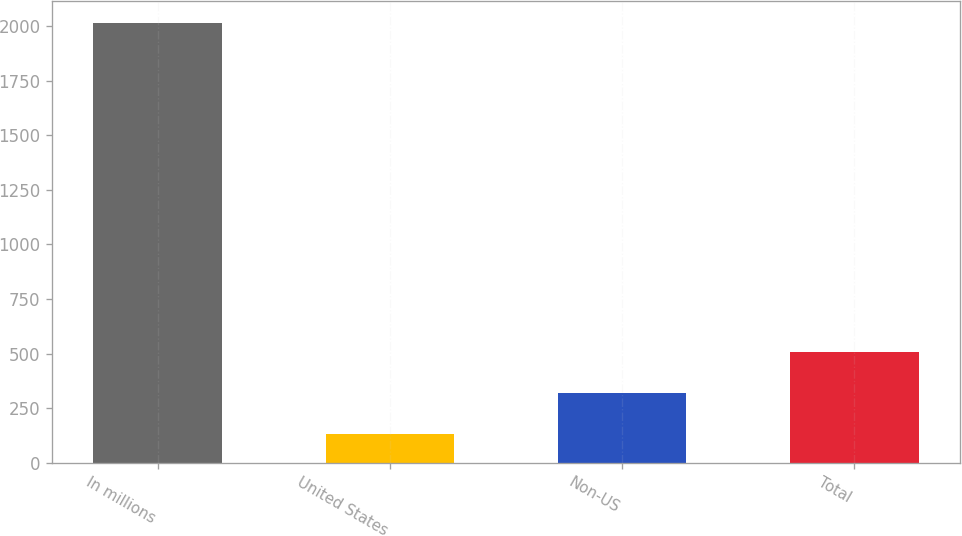Convert chart. <chart><loc_0><loc_0><loc_500><loc_500><bar_chart><fcel>In millions<fcel>United States<fcel>Non-US<fcel>Total<nl><fcel>2016<fcel>129.9<fcel>318.51<fcel>507.12<nl></chart> 